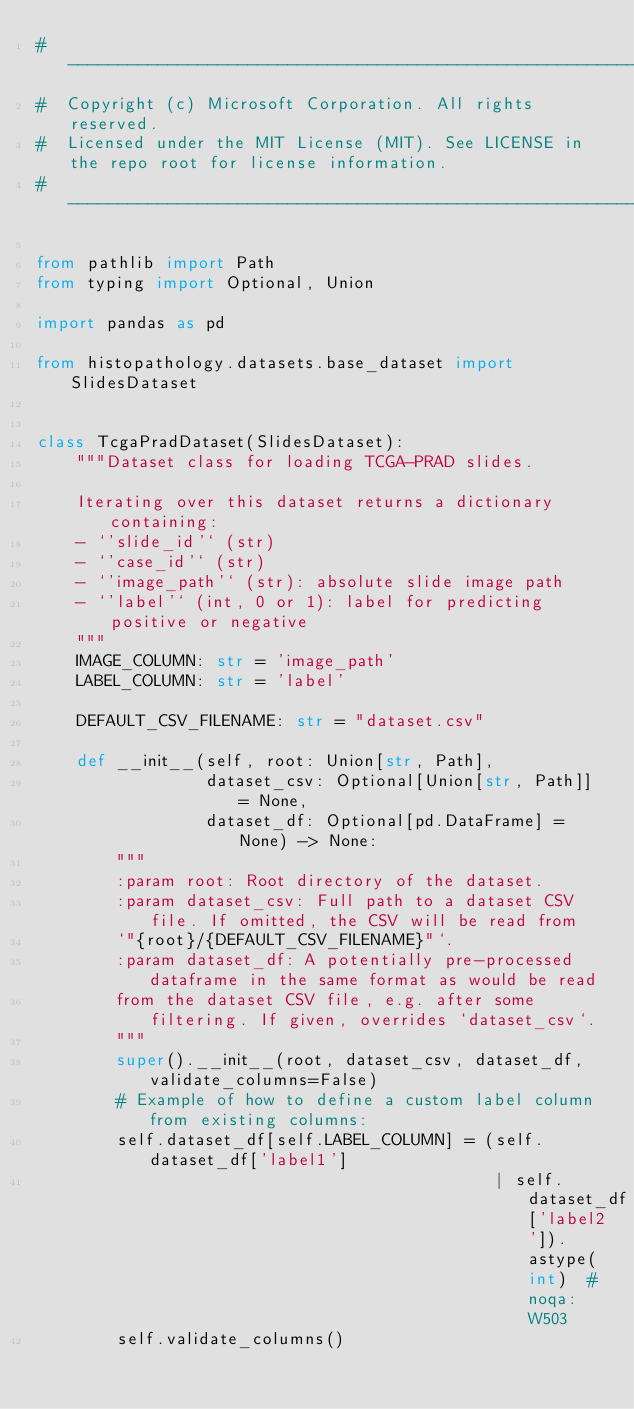<code> <loc_0><loc_0><loc_500><loc_500><_Python_>#  ------------------------------------------------------------------------------------------
#  Copyright (c) Microsoft Corporation. All rights reserved.
#  Licensed under the MIT License (MIT). See LICENSE in the repo root for license information.
#  ------------------------------------------------------------------------------------------

from pathlib import Path
from typing import Optional, Union

import pandas as pd

from histopathology.datasets.base_dataset import SlidesDataset


class TcgaPradDataset(SlidesDataset):
    """Dataset class for loading TCGA-PRAD slides.

    Iterating over this dataset returns a dictionary containing:
    - `'slide_id'` (str)
    - `'case_id'` (str)
    - `'image_path'` (str): absolute slide image path
    - `'label'` (int, 0 or 1): label for predicting positive or negative
    """
    IMAGE_COLUMN: str = 'image_path'
    LABEL_COLUMN: str = 'label'

    DEFAULT_CSV_FILENAME: str = "dataset.csv"

    def __init__(self, root: Union[str, Path],
                 dataset_csv: Optional[Union[str, Path]] = None,
                 dataset_df: Optional[pd.DataFrame] = None) -> None:
        """
        :param root: Root directory of the dataset.
        :param dataset_csv: Full path to a dataset CSV file. If omitted, the CSV will be read from
        `"{root}/{DEFAULT_CSV_FILENAME}"`.
        :param dataset_df: A potentially pre-processed dataframe in the same format as would be read
        from the dataset CSV file, e.g. after some filtering. If given, overrides `dataset_csv`.
        """
        super().__init__(root, dataset_csv, dataset_df, validate_columns=False)
        # Example of how to define a custom label column from existing columns:
        self.dataset_df[self.LABEL_COLUMN] = (self.dataset_df['label1']
                                              | self.dataset_df['label2']).astype(int)  # noqa: W503
        self.validate_columns()
</code> 